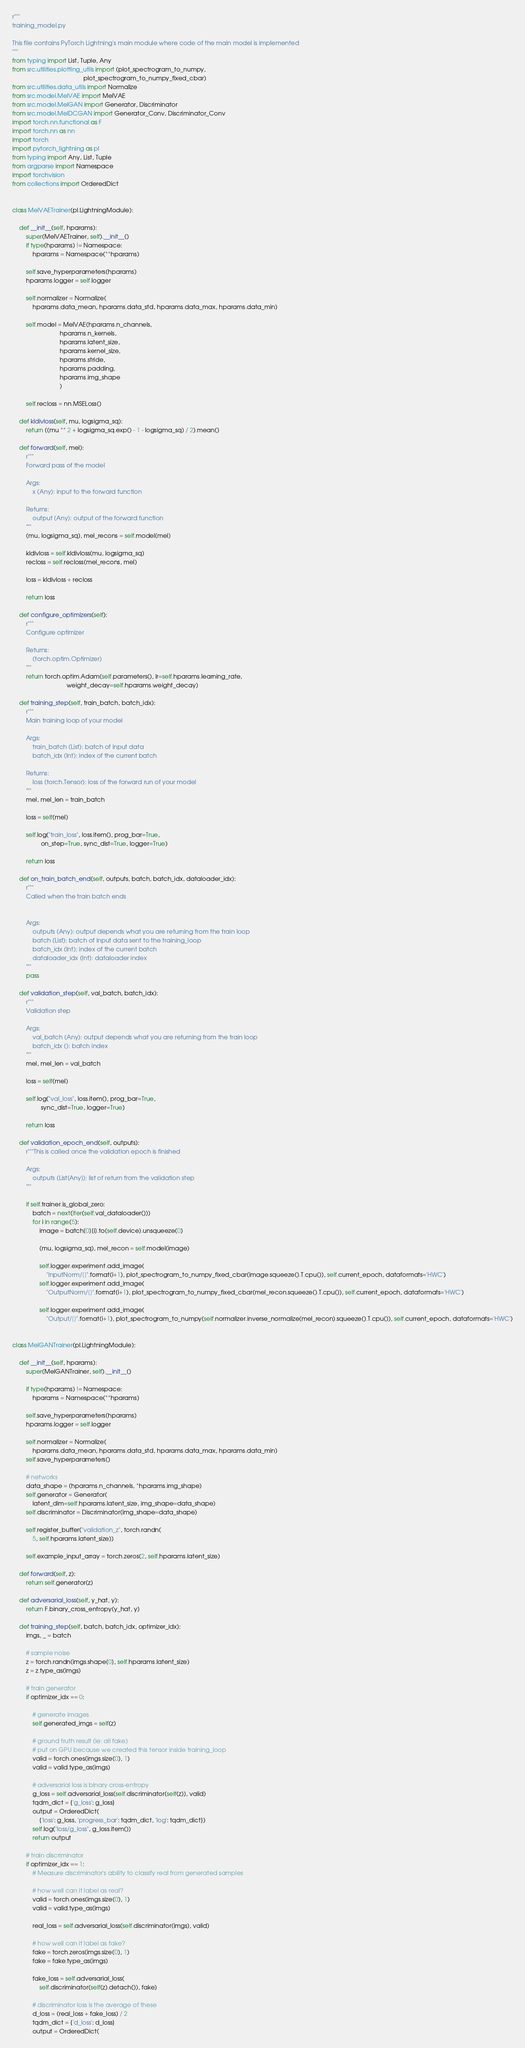<code> <loc_0><loc_0><loc_500><loc_500><_Python_>r"""
training_model.py

This file contains PyTorch Lightning's main module where code of the main model is implemented
"""
from typing import List, Tuple, Any
from src.utilities.plotting_utils import (plot_spectrogram_to_numpy,
                                          plot_spectrogram_to_numpy_fixed_cbar)
from src.utilities.data_utils import Normalize
from src.model.MelVAE import MelVAE
from src.model.MelGAN import Generator, Discriminator
from src.model.MelDCGAN import Generator_Conv, Discriminator_Conv
import torch.nn.functional as F
import torch.nn as nn
import torch
import pytorch_lightning as pl
from typing import Any, List, Tuple
from argparse import Namespace
import torchvision
from collections import OrderedDict


class MelVAETrainer(pl.LightningModule):

    def __init__(self, hparams):
        super(MelVAETrainer, self).__init__()
        if type(hparams) != Namespace:
            hparams = Namespace(**hparams)

        self.save_hyperparameters(hparams)
        hparams.logger = self.logger

        self.normalizer = Normalize(
            hparams.data_mean, hparams.data_std, hparams.data_max, hparams.data_min)

        self.model = MelVAE(hparams.n_channels,
                            hparams.n_kernels,
                            hparams.latent_size,
                            hparams.kernel_size,
                            hparams.stride,
                            hparams.padding,
                            hparams.img_shape
                            )

        self.recloss = nn.MSELoss()

    def kldivloss(self, mu, logsigma_sq):
        return ((mu ** 2 + logsigma_sq.exp() - 1 - logsigma_sq) / 2).mean()

    def forward(self, mel):
        r"""
        Forward pass of the model

        Args:
            x (Any): input to the forward function

        Returns:
            output (Any): output of the forward function
        """
        (mu, logsigma_sq), mel_recons = self.model(mel)

        kldivloss = self.kldivloss(mu, logsigma_sq)
        recloss = self.recloss(mel_recons, mel)

        loss = kldivloss + recloss

        return loss

    def configure_optimizers(self):
        r"""
        Configure optimizer

        Returns:
            (torch.optim.Optimizer)
        """
        return torch.optim.Adam(self.parameters(), lr=self.hparams.learning_rate,
                                weight_decay=self.hparams.weight_decay)

    def training_step(self, train_batch, batch_idx):
        r"""
        Main training loop of your model

        Args:
            train_batch (List): batch of input data
            batch_idx (Int): index of the current batch

        Returns:
            loss (torch.Tensor): loss of the forward run of your model
        """
        mel, mel_len = train_batch

        loss = self(mel)

        self.log("train_loss", loss.item(), prog_bar=True,
                 on_step=True, sync_dist=True, logger=True)

        return loss

    def on_train_batch_end(self, outputs, batch, batch_idx, dataloader_idx):
        r"""
        Called when the train batch ends


        Args:
            outputs (Any): output depends what you are returning from the train loop
            batch (List): batch of input data sent to the training_loop
            batch_idx (Int): index of the current batch
            dataloader_idx (Int): dataloader index
        """
        pass

    def validation_step(self, val_batch, batch_idx):
        r"""
        Validation step

        Args:
            val_batch (Any): output depends what you are returning from the train loop
            batch_idx (): batch index
        """
        mel, mel_len = val_batch

        loss = self(mel)

        self.log("val_loss", loss.item(), prog_bar=True,
                 sync_dist=True, logger=True)

        return loss

    def validation_epoch_end(self, outputs):
        r"""This is called once the validation epoch is finished

        Args:
            outputs (List[Any]): list of return from the validation step
        """

        if self.trainer.is_global_zero:
            batch = next(iter(self.val_dataloader()))
            for i in range(5):
                image = batch[0][i].to(self.device).unsqueeze(0)

                (mu, logsigma_sq), mel_recon = self.model(image)

                self.logger.experiment.add_image(
                    "InputNorm/{}".format(i+1), plot_spectrogram_to_numpy_fixed_cbar(image.squeeze().T.cpu()), self.current_epoch, dataformats='HWC')
                self.logger.experiment.add_image(
                    "OutputNorm/{}".format(i+1), plot_spectrogram_to_numpy_fixed_cbar(mel_recon.squeeze().T.cpu()), self.current_epoch, dataformats='HWC')

                self.logger.experiment.add_image(
                    "Output/{}".format(i+1), plot_spectrogram_to_numpy(self.normalizer.inverse_normalize(mel_recon).squeeze().T.cpu()), self.current_epoch, dataformats='HWC')


class MelGANTrainer(pl.LightningModule):

    def __init__(self, hparams):
        super(MelGANTrainer, self).__init__()

        if type(hparams) != Namespace:
            hparams = Namespace(**hparams)

        self.save_hyperparameters(hparams)
        hparams.logger = self.logger

        self.normalizer = Normalize(
            hparams.data_mean, hparams.data_std, hparams.data_max, hparams.data_min)
        self.save_hyperparameters()

        # networks
        data_shape = (hparams.n_channels, *hparams.img_shape)
        self.generator = Generator(
            latent_dim=self.hparams.latent_size, img_shape=data_shape)
        self.discriminator = Discriminator(img_shape=data_shape)

        self.register_buffer("validation_z", torch.randn(
            5, self.hparams.latent_size))

        self.example_input_array = torch.zeros(2, self.hparams.latent_size)

    def forward(self, z):
        return self.generator(z)

    def adversarial_loss(self, y_hat, y):
        return F.binary_cross_entropy(y_hat, y)

    def training_step(self, batch, batch_idx, optimizer_idx):
        imgs, _ = batch

        # sample noise
        z = torch.randn(imgs.shape[0], self.hparams.latent_size)
        z = z.type_as(imgs)

        # train generator
        if optimizer_idx == 0:

            # generate images
            self.generated_imgs = self(z)

            # ground truth result (ie: all fake)
            # put on GPU because we created this tensor inside training_loop
            valid = torch.ones(imgs.size(0), 1)
            valid = valid.type_as(imgs)

            # adversarial loss is binary cross-entropy
            g_loss = self.adversarial_loss(self.discriminator(self(z)), valid)
            tqdm_dict = {'g_loss': g_loss}
            output = OrderedDict(
                {'loss': g_loss, 'progress_bar': tqdm_dict, 'log': tqdm_dict})
            self.log("loss/g_loss", g_loss.item())
            return output

        # train discriminator
        if optimizer_idx == 1:
            # Measure discriminator's ability to classify real from generated samples

            # how well can it label as real?
            valid = torch.ones(imgs.size(0), 1)
            valid = valid.type_as(imgs)

            real_loss = self.adversarial_loss(self.discriminator(imgs), valid)

            # how well can it label as fake?
            fake = torch.zeros(imgs.size(0), 1)
            fake = fake.type_as(imgs)

            fake_loss = self.adversarial_loss(
                self.discriminator(self(z).detach()), fake)

            # discriminator loss is the average of these
            d_loss = (real_loss + fake_loss) / 2
            tqdm_dict = {'d_loss': d_loss}
            output = OrderedDict(</code> 